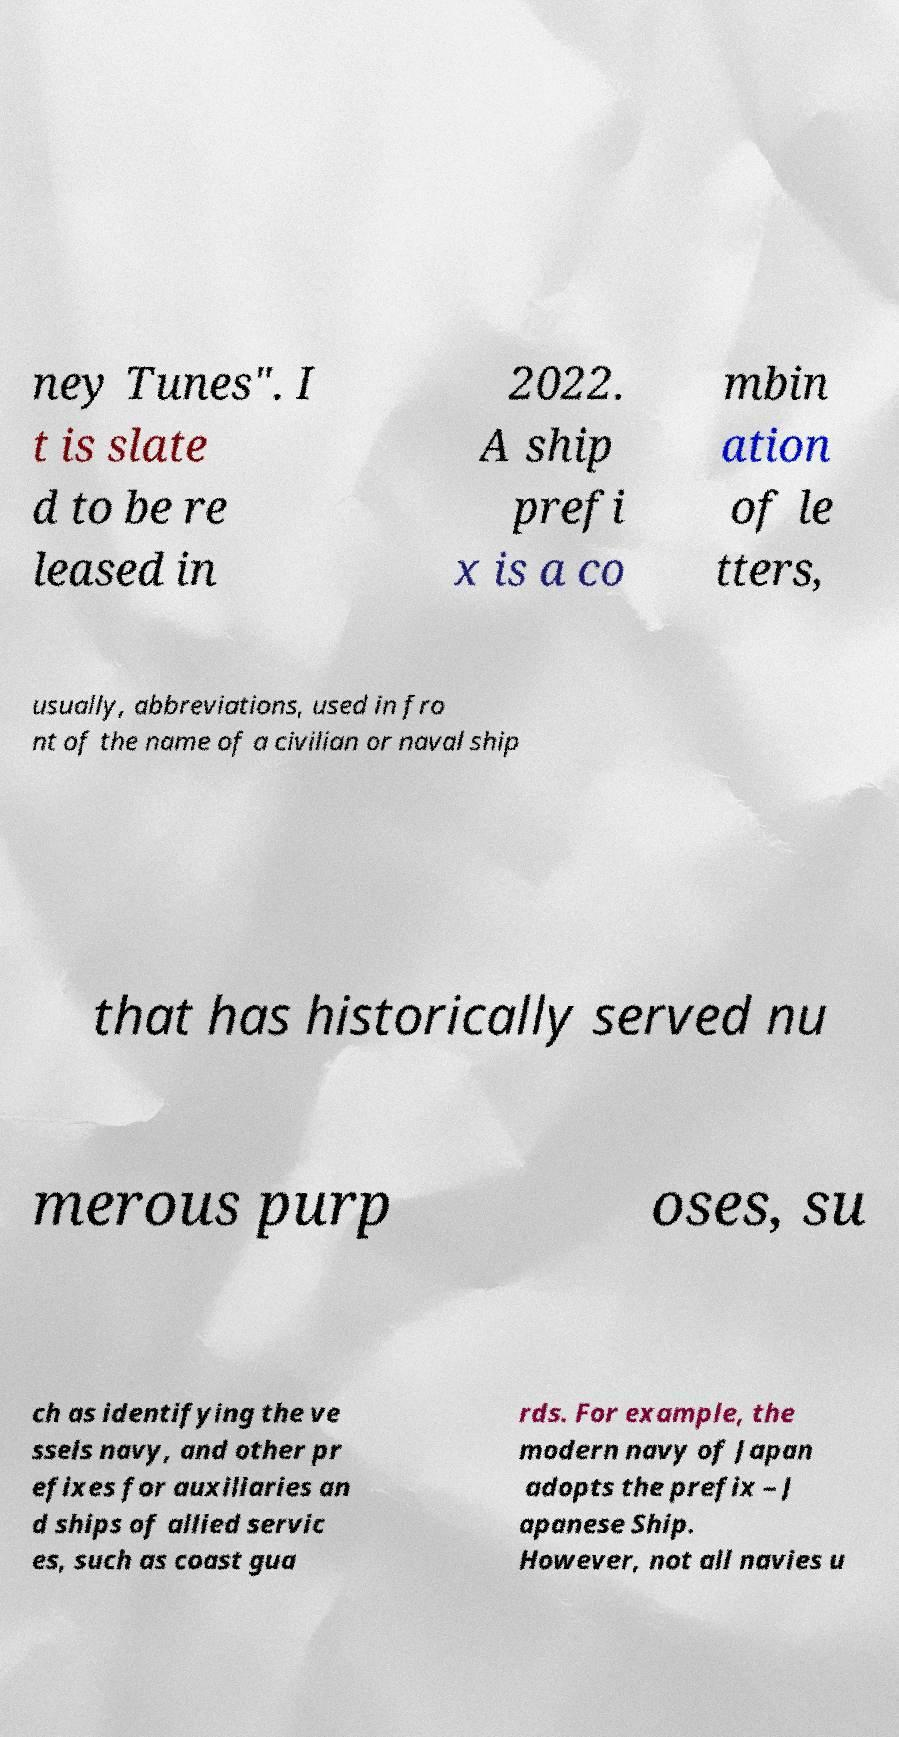I need the written content from this picture converted into text. Can you do that? ney Tunes". I t is slate d to be re leased in 2022. A ship prefi x is a co mbin ation of le tters, usually, abbreviations, used in fro nt of the name of a civilian or naval ship that has historically served nu merous purp oses, su ch as identifying the ve ssels navy, and other pr efixes for auxiliaries an d ships of allied servic es, such as coast gua rds. For example, the modern navy of Japan adopts the prefix – J apanese Ship. However, not all navies u 